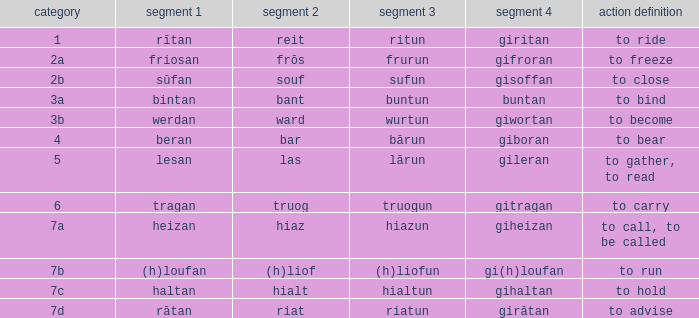What is the verb meaning of the word with part 2 "bant"? To bind. 